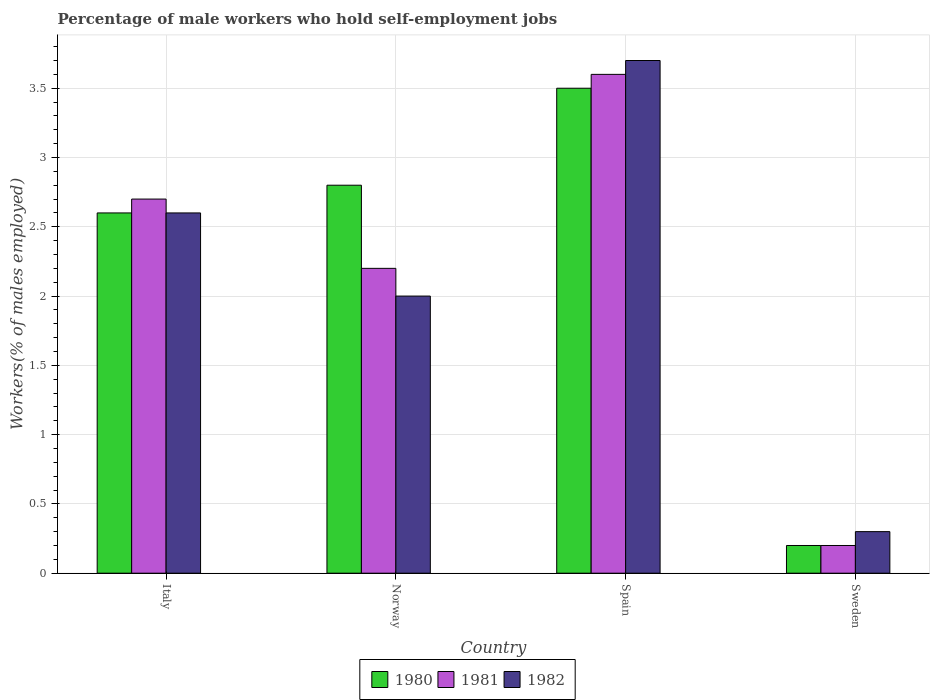How many different coloured bars are there?
Ensure brevity in your answer.  3. Are the number of bars on each tick of the X-axis equal?
Your answer should be compact. Yes. How many bars are there on the 2nd tick from the left?
Give a very brief answer. 3. In how many cases, is the number of bars for a given country not equal to the number of legend labels?
Provide a short and direct response. 0. What is the percentage of self-employed male workers in 1981 in Sweden?
Your answer should be compact. 0.2. Across all countries, what is the maximum percentage of self-employed male workers in 1981?
Keep it short and to the point. 3.6. Across all countries, what is the minimum percentage of self-employed male workers in 1982?
Offer a very short reply. 0.3. In which country was the percentage of self-employed male workers in 1981 maximum?
Provide a succinct answer. Spain. What is the total percentage of self-employed male workers in 1982 in the graph?
Your answer should be compact. 8.6. What is the difference between the percentage of self-employed male workers in 1980 in Italy and that in Spain?
Make the answer very short. -0.9. What is the difference between the percentage of self-employed male workers in 1981 in Italy and the percentage of self-employed male workers in 1982 in Sweden?
Give a very brief answer. 2.4. What is the average percentage of self-employed male workers in 1980 per country?
Offer a very short reply. 2.27. What is the difference between the percentage of self-employed male workers of/in 1982 and percentage of self-employed male workers of/in 1981 in Norway?
Offer a terse response. -0.2. In how many countries, is the percentage of self-employed male workers in 1981 greater than 1.1 %?
Offer a very short reply. 3. What is the ratio of the percentage of self-employed male workers in 1982 in Norway to that in Sweden?
Make the answer very short. 6.67. Is the percentage of self-employed male workers in 1981 in Italy less than that in Spain?
Offer a terse response. Yes. What is the difference between the highest and the second highest percentage of self-employed male workers in 1981?
Give a very brief answer. -0.5. What is the difference between the highest and the lowest percentage of self-employed male workers in 1981?
Your answer should be very brief. 3.4. In how many countries, is the percentage of self-employed male workers in 1980 greater than the average percentage of self-employed male workers in 1980 taken over all countries?
Your answer should be very brief. 3. What does the 2nd bar from the left in Italy represents?
Keep it short and to the point. 1981. Is it the case that in every country, the sum of the percentage of self-employed male workers in 1982 and percentage of self-employed male workers in 1980 is greater than the percentage of self-employed male workers in 1981?
Your response must be concise. Yes. How many countries are there in the graph?
Provide a succinct answer. 4. Are the values on the major ticks of Y-axis written in scientific E-notation?
Make the answer very short. No. Does the graph contain grids?
Keep it short and to the point. Yes. How many legend labels are there?
Offer a very short reply. 3. How are the legend labels stacked?
Make the answer very short. Horizontal. What is the title of the graph?
Make the answer very short. Percentage of male workers who hold self-employment jobs. Does "1966" appear as one of the legend labels in the graph?
Give a very brief answer. No. What is the label or title of the Y-axis?
Your answer should be compact. Workers(% of males employed). What is the Workers(% of males employed) of 1980 in Italy?
Your answer should be very brief. 2.6. What is the Workers(% of males employed) in 1981 in Italy?
Your answer should be very brief. 2.7. What is the Workers(% of males employed) in 1982 in Italy?
Offer a terse response. 2.6. What is the Workers(% of males employed) of 1980 in Norway?
Offer a terse response. 2.8. What is the Workers(% of males employed) in 1981 in Norway?
Offer a terse response. 2.2. What is the Workers(% of males employed) of 1982 in Norway?
Keep it short and to the point. 2. What is the Workers(% of males employed) in 1981 in Spain?
Provide a short and direct response. 3.6. What is the Workers(% of males employed) in 1982 in Spain?
Provide a short and direct response. 3.7. What is the Workers(% of males employed) of 1980 in Sweden?
Make the answer very short. 0.2. What is the Workers(% of males employed) of 1981 in Sweden?
Offer a terse response. 0.2. What is the Workers(% of males employed) in 1982 in Sweden?
Offer a very short reply. 0.3. Across all countries, what is the maximum Workers(% of males employed) of 1981?
Provide a short and direct response. 3.6. Across all countries, what is the maximum Workers(% of males employed) of 1982?
Offer a terse response. 3.7. Across all countries, what is the minimum Workers(% of males employed) in 1980?
Your answer should be very brief. 0.2. Across all countries, what is the minimum Workers(% of males employed) in 1981?
Your answer should be compact. 0.2. Across all countries, what is the minimum Workers(% of males employed) in 1982?
Ensure brevity in your answer.  0.3. What is the total Workers(% of males employed) in 1980 in the graph?
Ensure brevity in your answer.  9.1. What is the difference between the Workers(% of males employed) of 1982 in Italy and that in Norway?
Give a very brief answer. 0.6. What is the difference between the Workers(% of males employed) in 1981 in Italy and that in Spain?
Keep it short and to the point. -0.9. What is the difference between the Workers(% of males employed) in 1982 in Italy and that in Spain?
Your answer should be very brief. -1.1. What is the difference between the Workers(% of males employed) of 1980 in Italy and that in Sweden?
Give a very brief answer. 2.4. What is the difference between the Workers(% of males employed) of 1981 in Italy and that in Sweden?
Provide a short and direct response. 2.5. What is the difference between the Workers(% of males employed) in 1982 in Italy and that in Sweden?
Provide a short and direct response. 2.3. What is the difference between the Workers(% of males employed) of 1980 in Norway and that in Spain?
Your response must be concise. -0.7. What is the difference between the Workers(% of males employed) in 1981 in Norway and that in Spain?
Offer a terse response. -1.4. What is the difference between the Workers(% of males employed) in 1980 in Norway and that in Sweden?
Keep it short and to the point. 2.6. What is the difference between the Workers(% of males employed) of 1982 in Norway and that in Sweden?
Offer a very short reply. 1.7. What is the difference between the Workers(% of males employed) in 1980 in Spain and that in Sweden?
Provide a short and direct response. 3.3. What is the difference between the Workers(% of males employed) of 1980 in Italy and the Workers(% of males employed) of 1981 in Norway?
Provide a succinct answer. 0.4. What is the difference between the Workers(% of males employed) of 1980 in Italy and the Workers(% of males employed) of 1982 in Norway?
Your answer should be compact. 0.6. What is the difference between the Workers(% of males employed) of 1980 in Italy and the Workers(% of males employed) of 1981 in Spain?
Give a very brief answer. -1. What is the difference between the Workers(% of males employed) of 1980 in Italy and the Workers(% of males employed) of 1982 in Spain?
Your response must be concise. -1.1. What is the difference between the Workers(% of males employed) in 1980 in Italy and the Workers(% of males employed) in 1981 in Sweden?
Your response must be concise. 2.4. What is the difference between the Workers(% of males employed) of 1981 in Italy and the Workers(% of males employed) of 1982 in Sweden?
Give a very brief answer. 2.4. What is the difference between the Workers(% of males employed) in 1980 in Norway and the Workers(% of males employed) in 1982 in Spain?
Offer a very short reply. -0.9. What is the difference between the Workers(% of males employed) in 1980 in Norway and the Workers(% of males employed) in 1981 in Sweden?
Your answer should be very brief. 2.6. What is the difference between the Workers(% of males employed) in 1980 in Norway and the Workers(% of males employed) in 1982 in Sweden?
Make the answer very short. 2.5. What is the difference between the Workers(% of males employed) in 1980 in Spain and the Workers(% of males employed) in 1981 in Sweden?
Your answer should be compact. 3.3. What is the difference between the Workers(% of males employed) of 1980 in Spain and the Workers(% of males employed) of 1982 in Sweden?
Offer a very short reply. 3.2. What is the average Workers(% of males employed) in 1980 per country?
Keep it short and to the point. 2.27. What is the average Workers(% of males employed) in 1981 per country?
Ensure brevity in your answer.  2.17. What is the average Workers(% of males employed) in 1982 per country?
Your response must be concise. 2.15. What is the difference between the Workers(% of males employed) of 1980 and Workers(% of males employed) of 1981 in Italy?
Your answer should be very brief. -0.1. What is the difference between the Workers(% of males employed) of 1980 and Workers(% of males employed) of 1981 in Norway?
Provide a short and direct response. 0.6. What is the difference between the Workers(% of males employed) in 1980 and Workers(% of males employed) in 1981 in Spain?
Your answer should be compact. -0.1. What is the difference between the Workers(% of males employed) of 1980 and Workers(% of males employed) of 1982 in Spain?
Your answer should be very brief. -0.2. What is the difference between the Workers(% of males employed) of 1980 and Workers(% of males employed) of 1981 in Sweden?
Make the answer very short. 0. What is the difference between the Workers(% of males employed) of 1980 and Workers(% of males employed) of 1982 in Sweden?
Offer a terse response. -0.1. What is the ratio of the Workers(% of males employed) in 1980 in Italy to that in Norway?
Keep it short and to the point. 0.93. What is the ratio of the Workers(% of males employed) of 1981 in Italy to that in Norway?
Provide a short and direct response. 1.23. What is the ratio of the Workers(% of males employed) of 1982 in Italy to that in Norway?
Give a very brief answer. 1.3. What is the ratio of the Workers(% of males employed) of 1980 in Italy to that in Spain?
Keep it short and to the point. 0.74. What is the ratio of the Workers(% of males employed) of 1982 in Italy to that in Spain?
Keep it short and to the point. 0.7. What is the ratio of the Workers(% of males employed) of 1980 in Italy to that in Sweden?
Offer a terse response. 13. What is the ratio of the Workers(% of males employed) of 1981 in Italy to that in Sweden?
Provide a short and direct response. 13.5. What is the ratio of the Workers(% of males employed) of 1982 in Italy to that in Sweden?
Keep it short and to the point. 8.67. What is the ratio of the Workers(% of males employed) in 1980 in Norway to that in Spain?
Make the answer very short. 0.8. What is the ratio of the Workers(% of males employed) in 1981 in Norway to that in Spain?
Offer a very short reply. 0.61. What is the ratio of the Workers(% of males employed) in 1982 in Norway to that in Spain?
Give a very brief answer. 0.54. What is the ratio of the Workers(% of males employed) in 1981 in Norway to that in Sweden?
Offer a terse response. 11. What is the ratio of the Workers(% of males employed) of 1980 in Spain to that in Sweden?
Your answer should be compact. 17.5. What is the ratio of the Workers(% of males employed) in 1982 in Spain to that in Sweden?
Your response must be concise. 12.33. What is the difference between the highest and the second highest Workers(% of males employed) of 1980?
Keep it short and to the point. 0.7. What is the difference between the highest and the second highest Workers(% of males employed) of 1982?
Make the answer very short. 1.1. What is the difference between the highest and the lowest Workers(% of males employed) of 1980?
Give a very brief answer. 3.3. 